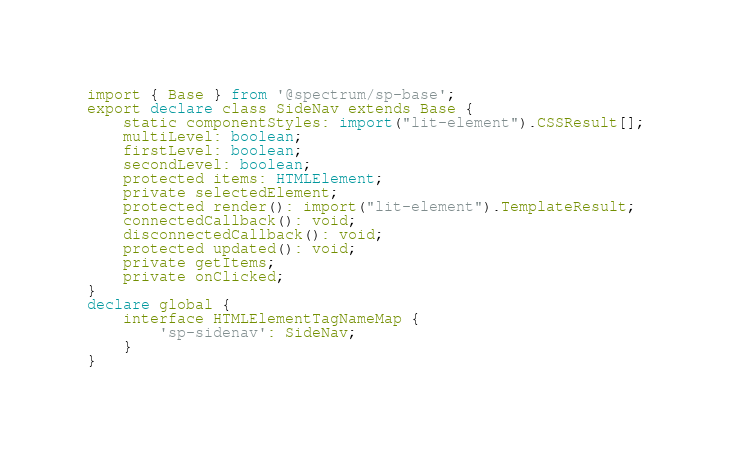Convert code to text. <code><loc_0><loc_0><loc_500><loc_500><_TypeScript_>import { Base } from '@spectrum/sp-base';
export declare class SideNav extends Base {
    static componentStyles: import("lit-element").CSSResult[];
    multiLevel: boolean;
    firstLevel: boolean;
    secondLevel: boolean;
    protected items: HTMLElement;
    private selectedElement;
    protected render(): import("lit-element").TemplateResult;
    connectedCallback(): void;
    disconnectedCallback(): void;
    protected updated(): void;
    private getItems;
    private onClicked;
}
declare global {
    interface HTMLElementTagNameMap {
        'sp-sidenav': SideNav;
    }
}
</code> 